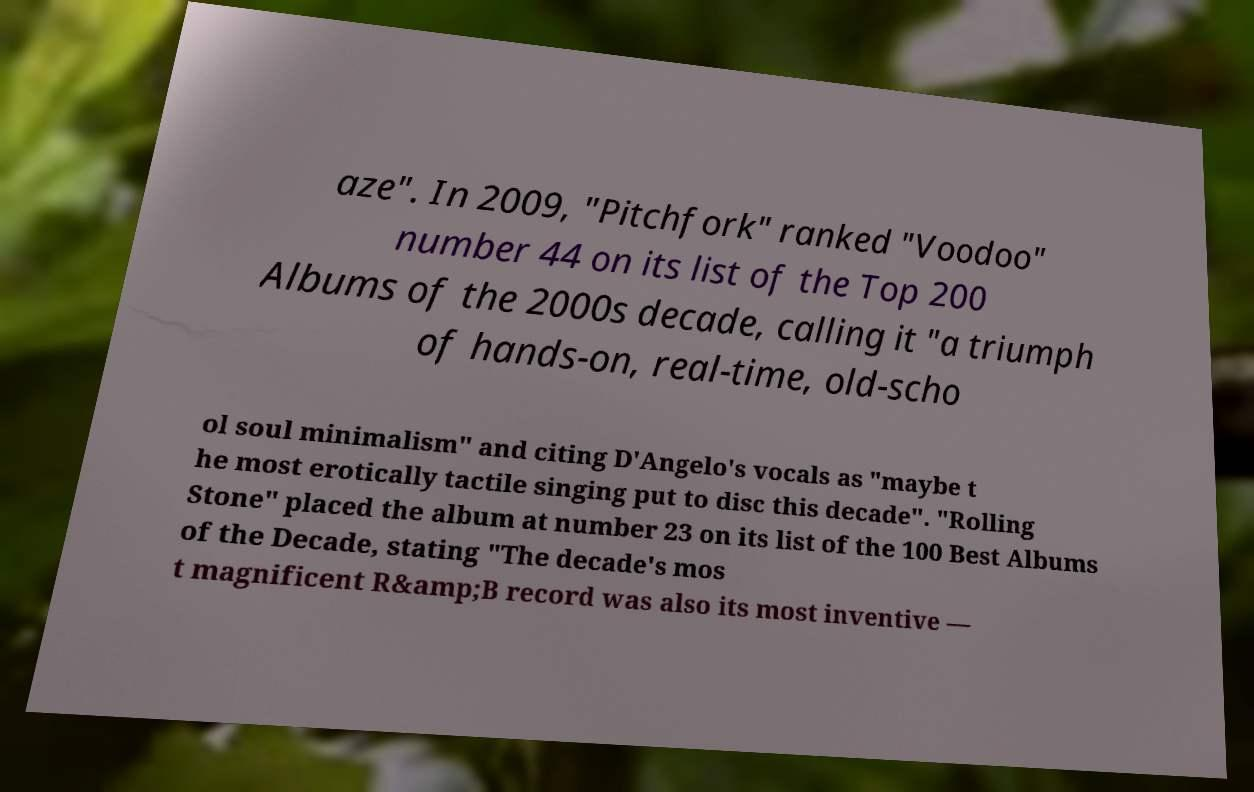Can you accurately transcribe the text from the provided image for me? aze". In 2009, "Pitchfork" ranked "Voodoo" number 44 on its list of the Top 200 Albums of the 2000s decade, calling it "a triumph of hands-on, real-time, old-scho ol soul minimalism" and citing D'Angelo's vocals as "maybe t he most erotically tactile singing put to disc this decade". "Rolling Stone" placed the album at number 23 on its list of the 100 Best Albums of the Decade, stating "The decade's mos t magnificent R&amp;B record was also its most inventive — 